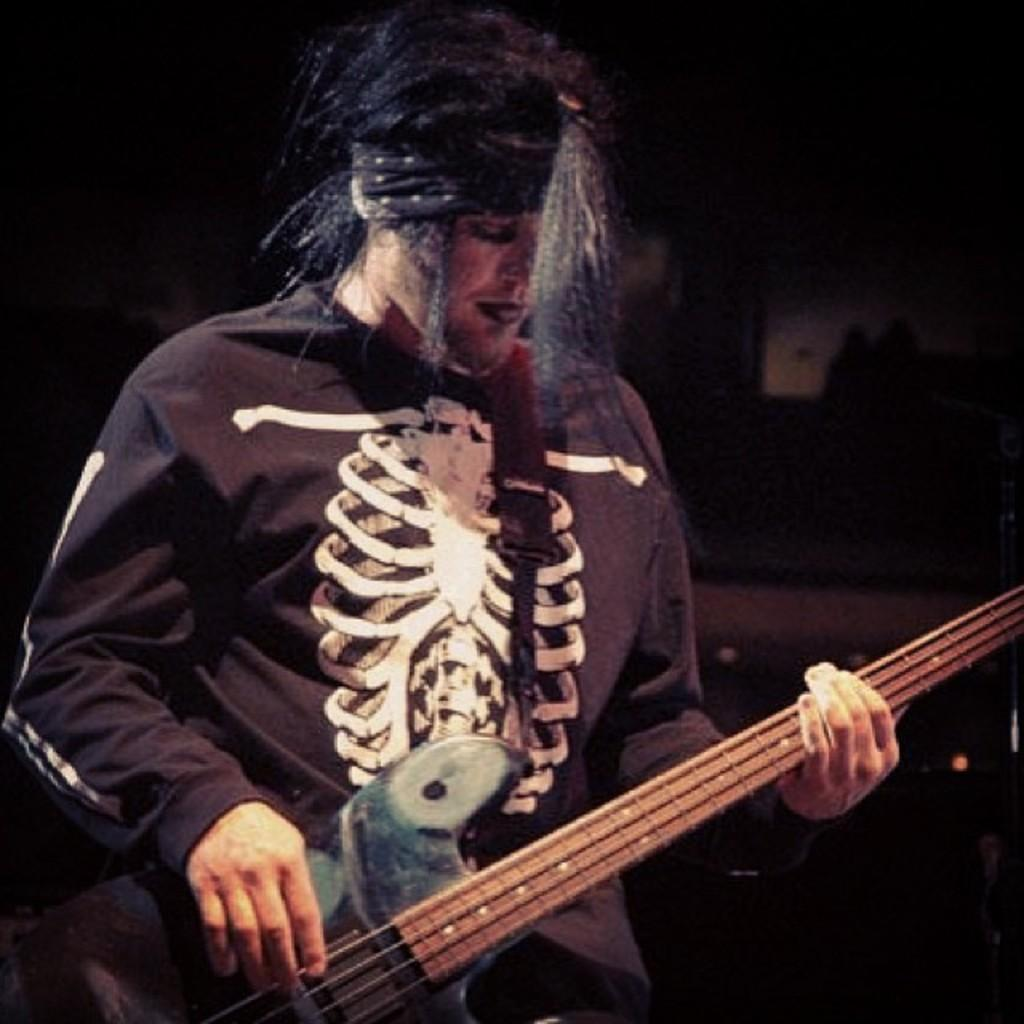What is the main subject of the image? There is a man standing in the middle of the image. What is the man holding in the image? The man is holding a music instrument. Can you describe the music instrument? The music instrument is yellow in color. Where is the pig located in the image? There is no pig present in the image. What type of love is being expressed in the image? The image does not depict any expression of love; it features a man holding a yellow music instrument. 